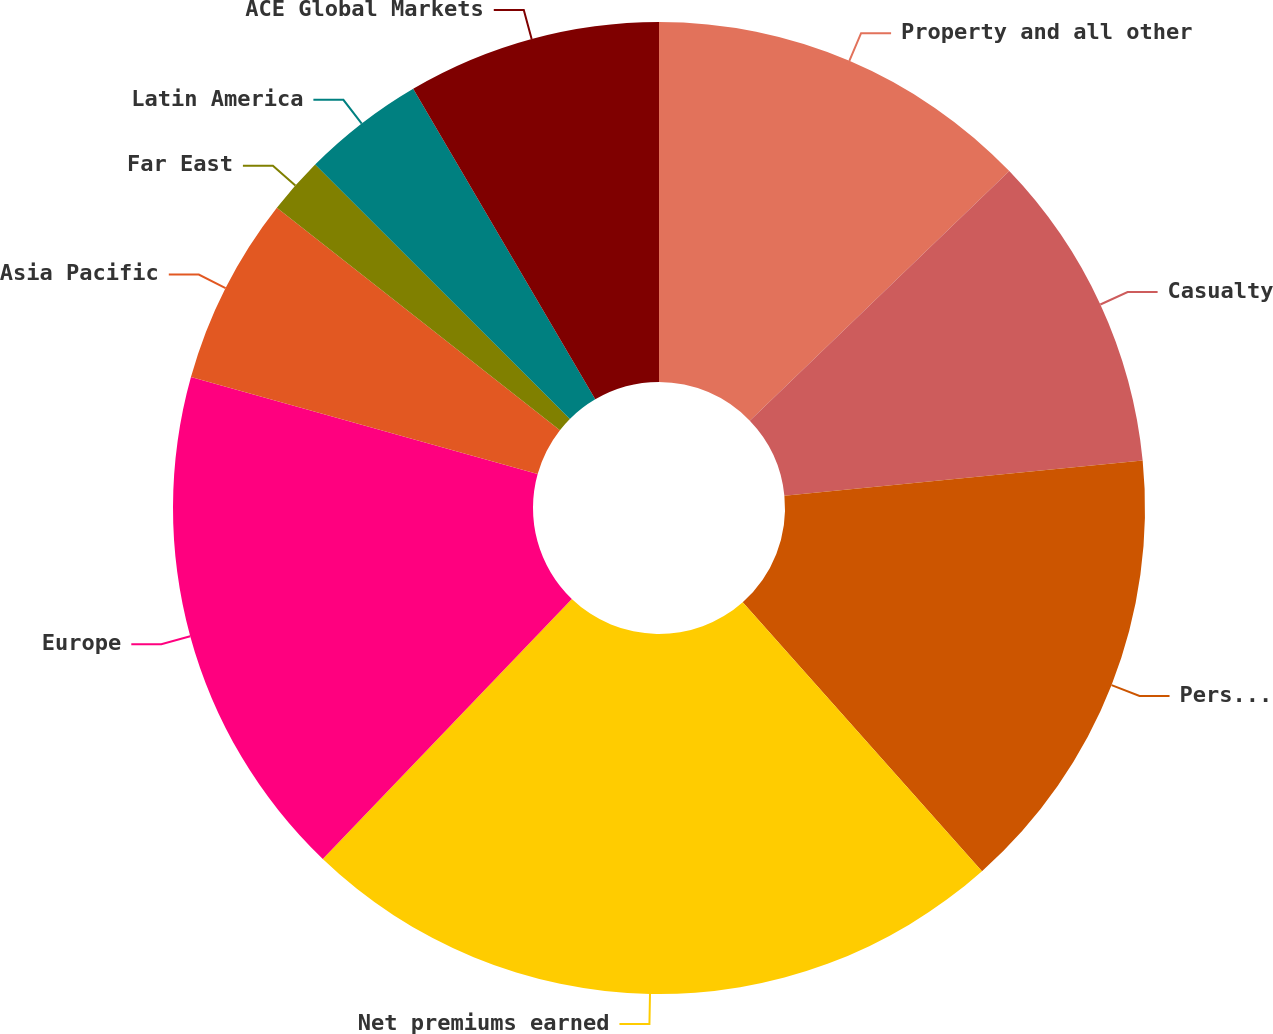Convert chart to OTSL. <chart><loc_0><loc_0><loc_500><loc_500><pie_chart><fcel>Property and all other<fcel>Casualty<fcel>Personal accident (A&H)<fcel>Net premiums earned<fcel>Europe<fcel>Asia Pacific<fcel>Far East<fcel>Latin America<fcel>ACE Global Markets<nl><fcel>12.81%<fcel>10.63%<fcel>14.99%<fcel>23.73%<fcel>17.18%<fcel>6.26%<fcel>1.89%<fcel>4.07%<fcel>8.44%<nl></chart> 